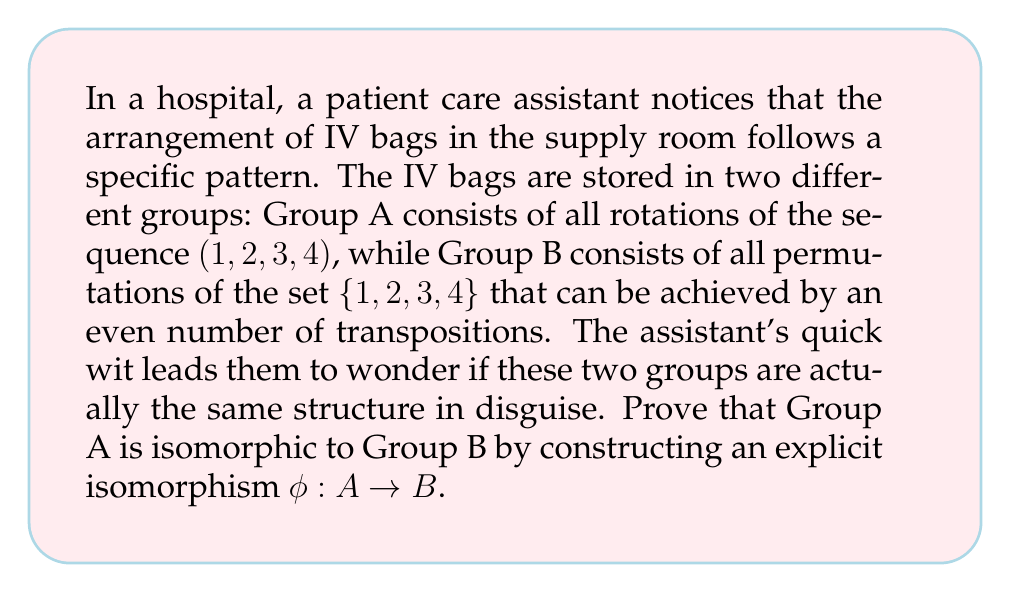Can you solve this math problem? To prove that Group A is isomorphic to Group B, we need to construct a bijective homomorphism $\phi: A \rightarrow B$. Let's approach this step-by-step:

1) First, let's identify the elements of each group:

   Group A (rotations of (1, 2, 3, 4)):
   $a_1 = (1, 2, 3, 4)$
   $a_2 = (4, 1, 2, 3)$
   $a_3 = (3, 4, 1, 2)$
   $a_4 = (2, 3, 4, 1)$

   Group B (even permutations of {1, 2, 3, 4}):
   $b_1 = (1)(2)(3)(4)$ (identity)
   $b_2 = (1 2 3)$
   $b_3 = (1 3 2)$
   $b_4 = (1 4 2 3)$

2) We can define our isomorphism $\phi: A \rightarrow B$ as follows:

   $\phi(a_1) = b_1$
   $\phi(a_2) = b_4$
   $\phi(a_3) = b_3$
   $\phi(a_4) = b_2$

3) To prove this is an isomorphism, we need to show it's bijective and preserves the group operation.

4) Bijectivity:
   - It's injective (one-to-one) because each element in A maps to a unique element in B.
   - It's surjective (onto) because every element in B is mapped to by an element in A.

5) Preserving the group operation:
   We need to show that for any $x, y \in A$, $\phi(xy) = \phi(x)\phi(y)$.

   Let's check this for $a_2 * a_3$:
   
   $a_2 * a_3 = (4, 1, 2, 3) * (3, 4, 1, 2) = (2, 3, 4, 1) = a_4$
   
   So, $\phi(a_2 * a_3) = \phi(a_4) = b_2$

   Now, $\phi(a_2)\phi(a_3) = b_4 * b_3 = (1 4 2 3)(1 3 2) = (1 2 3) = b_2$

   Indeed, $\phi(a_2 * a_3) = \phi(a_2)\phi(a_3)$

6) We can similarly verify this property for all other combinations of elements in A.

Therefore, $\phi$ is an isomorphism between Group A and Group B.
Answer: The isomorphism $\phi: A \rightarrow B$ is defined as:

$\phi(a_1) = b_1$
$\phi(a_2) = b_4$
$\phi(a_3) = b_3$
$\phi(a_4) = b_2$

This mapping is bijective and preserves the group operation, thus proving that Group A is isomorphic to Group B. 